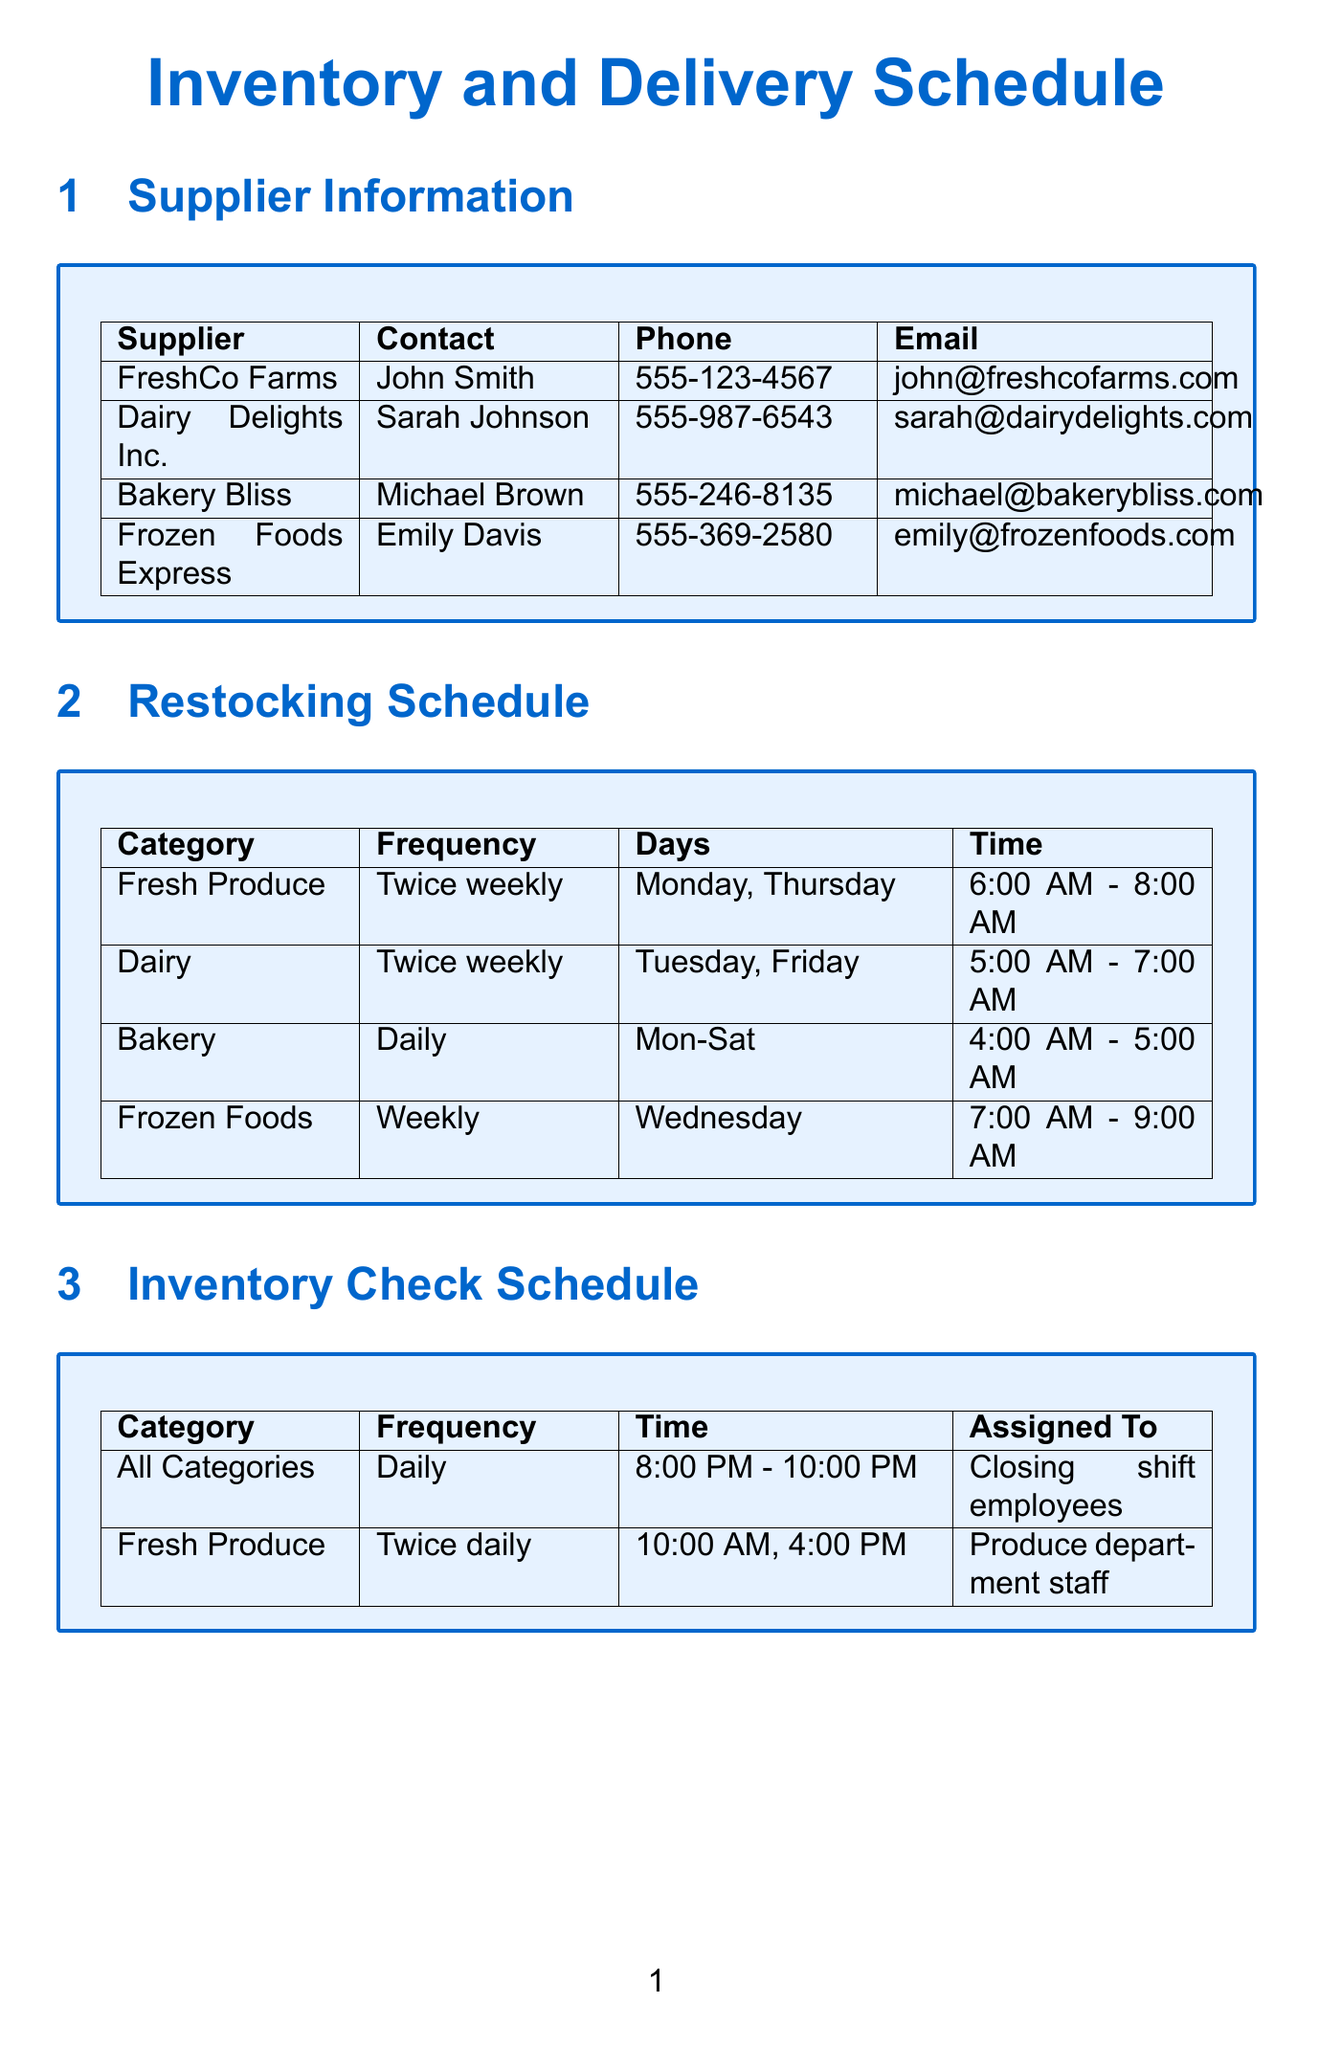What are the delivery days for FreshCo Farms? FreshCo Farms delivers on Monday and Thursday, as specified in the supplier details.
Answer: Monday, Thursday How often is Dairy restocked? The restocking schedule indicates that Dairy is restocked twice weekly.
Answer: Twice weekly What time does the Bakery restocking occur? The restocking time for Bakery is listed as 4:00 AM to 5:00 AM in the schedule.
Answer: 4:00 AM - 5:00 AM What training is required for assisting with deliveries? The document specifies that training required includes safe lifting techniques and delivery check-in procedures.
Answer: Safe lifting techniques and delivery check-in procedures Which supplier has the longest order placement deadline? Analyzing the order placement deadlines reveals that Frozen Foods Express has a 72-hour deadline before delivery.
Answer: 72 hours On which days is inventory checked for Fresh Produce? The inventory check schedule states that Fresh Produce is checked twice daily, which includes a time for both checks but does not mention specific days.
Answer: N/A (not specified) What is the suitable hour for checking inventory on weekdays? The suitable hours for inventory checking on weekdays are specified as 4:00 PM to 8:00 PM.
Answer: 4:00 PM - 8:00 PM When should orders be placed for Bakery Bliss? The document notes that orders must be placed 24 hours before delivery for Bakery Bliss.
Answer: 24 hours What contact number is listed for Dairy Delights Inc.? The contact number for Dairy Delights Inc. is given as 555-987-6543.
Answer: 555-987-6543 